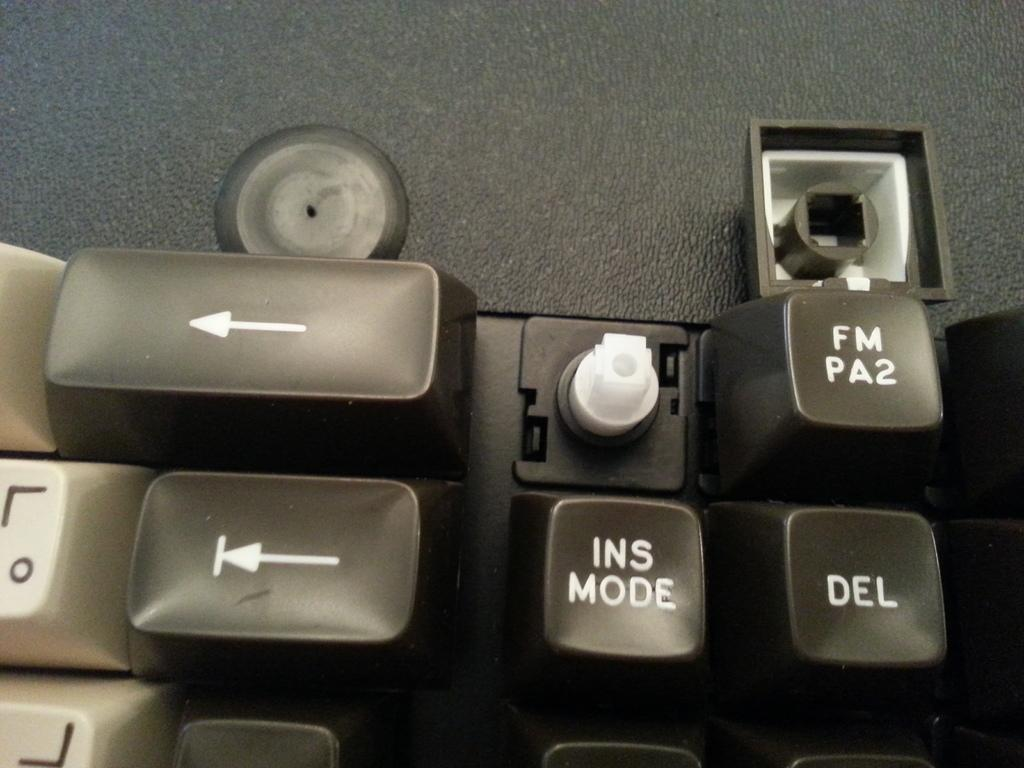<image>
Create a compact narrative representing the image presented. A black and white keyboard that is missing a key over the INS mode key. 